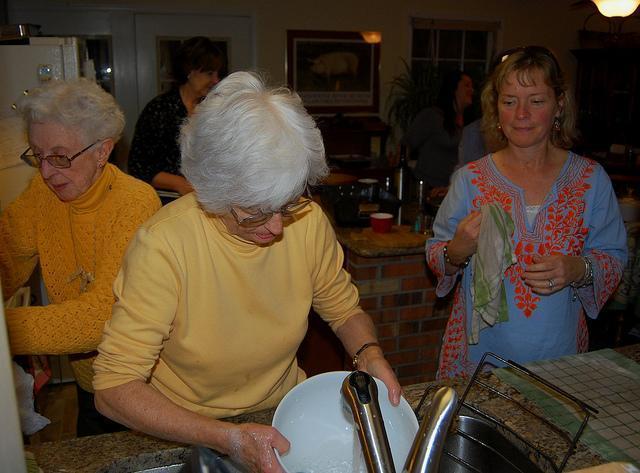How many people are there?
Give a very brief answer. 6. How many are wearing glasses?
Give a very brief answer. 2. How many people are in the photo?
Give a very brief answer. 5. 